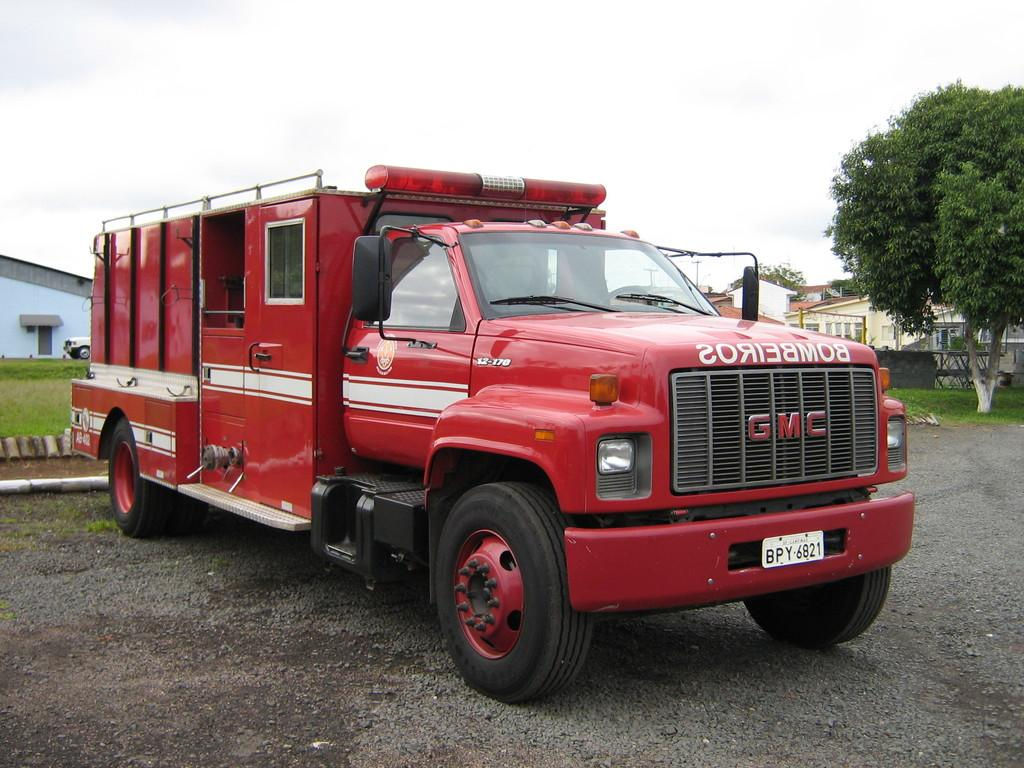What type of vehicles can be seen on the road in the image? There are motor vehicles on the road in the image. What type of natural vegetation is present in the image? There are trees and grass in the image. What type of man-made structures are present in the image? There are buildings in the image. What is visible in the sky in the image? The sky is visible in the image, and there are clouds in the sky. Where is the lunchroom located in the image? There is no lunchroom present in the image. What time of day is it in the image, based on the hour? The provided facts do not include any information about the time of day or the hour. Can you see any ants in the image? There is no mention of ants in the image. 